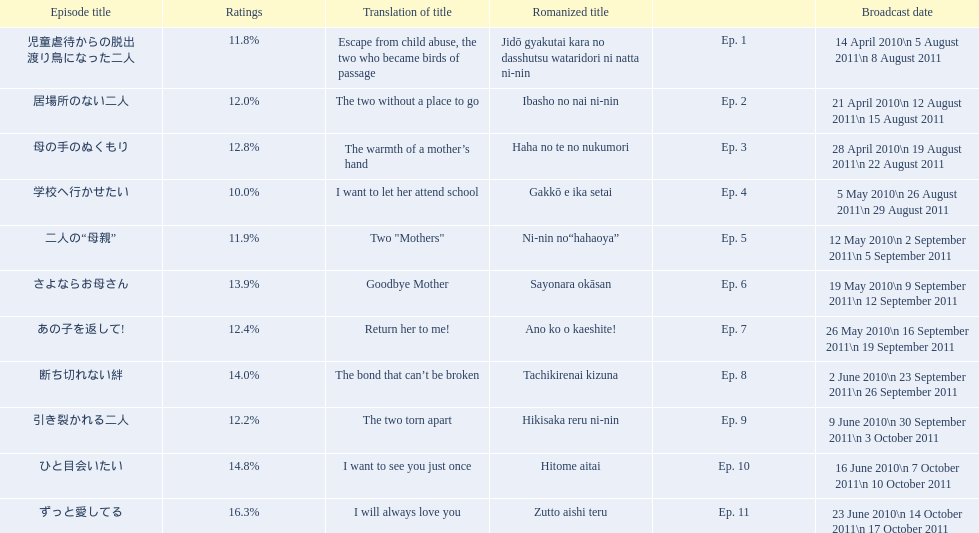What are all the titles the episodes of the mother tv series? 児童虐待からの脱出 渡り鳥になった二人, 居場所のない二人, 母の手のぬくもり, 学校へ行かせたい, 二人の“母親”, さよならお母さん, あの子を返して!, 断ち切れない絆, 引き裂かれる二人, ひと目会いたい, ずっと愛してる. What are all of the ratings for each of the shows? 11.8%, 12.0%, 12.8%, 10.0%, 11.9%, 13.9%, 12.4%, 14.0%, 12.2%, 14.8%, 16.3%. What is the highest score for ratings? 16.3%. What episode corresponds to that rating? ずっと愛してる. 